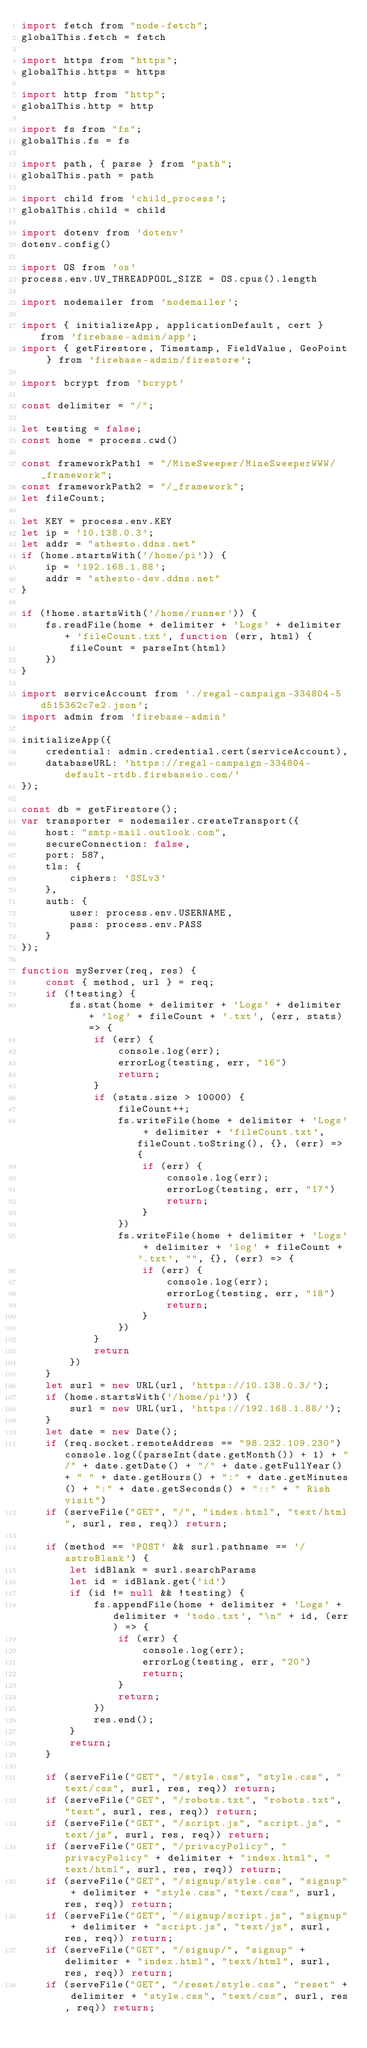<code> <loc_0><loc_0><loc_500><loc_500><_JavaScript_>import fetch from "node-fetch";
globalThis.fetch = fetch

import https from "https";
globalThis.https = https

import http from "http";
globalThis.http = http

import fs from "fs";
globalThis.fs = fs

import path, { parse } from "path";
globalThis.path = path

import child from 'child_process';
globalThis.child = child

import dotenv from 'dotenv'
dotenv.config()

import OS from 'os'
process.env.UV_THREADPOOL_SIZE = OS.cpus().length

import nodemailer from 'nodemailer';

import { initializeApp, applicationDefault, cert } from 'firebase-admin/app';
import { getFirestore, Timestamp, FieldValue, GeoPoint } from 'firebase-admin/firestore';

import bcrypt from 'bcrypt'

const delimiter = "/";

let testing = false;
const home = process.cwd()

const frameworkPath1 = "/MineSweeper/MineSweeperWWW/_framework";
const frameworkPath2 = "/_framework";
let fileCount;

let KEY = process.env.KEY
let ip = '10.138.0.3';
let addr = "athesto.ddns.net"
if (home.startsWith('/home/pi')) {
    ip = '192.168.1.88';
    addr = "athesto-dev.ddns.net"
}

if (!home.startsWith('/home/runner')) {
    fs.readFile(home + delimiter + 'Logs' + delimiter + 'fileCount.txt', function (err, html) {
        fileCount = parseInt(html)
    })
}

import serviceAccount from './regal-campaign-334804-5d515362c7e2.json';
import admin from 'firebase-admin'

initializeApp({
    credential: admin.credential.cert(serviceAccount),
    databaseURL: 'https://regal-campaign-334804-default-rtdb.firebaseio.com/'
});

const db = getFirestore();
var transporter = nodemailer.createTransport({
    host: "smtp-mail.outlook.com",
    secureConnection: false,
    port: 587,
    tls: {
        ciphers: 'SSLv3'
    },
    auth: {
        user: process.env.USERNAME,
        pass: process.env.PASS
    }
});

function myServer(req, res) {
    const { method, url } = req;
    if (!testing) {
        fs.stat(home + delimiter + 'Logs' + delimiter + 'log' + fileCount + '.txt', (err, stats) => {
            if (err) {
                console.log(err);
                errorLog(testing, err, "16")
                return;
            }
            if (stats.size > 10000) {
                fileCount++;
                fs.writeFile(home + delimiter + 'Logs' + delimiter + 'fileCount.txt', fileCount.toString(), {}, (err) => {
                    if (err) {
                        console.log(err);
                        errorLog(testing, err, "17")
                        return;
                    }
                })
                fs.writeFile(home + delimiter + 'Logs' + delimiter + 'log' + fileCount + '.txt', "", {}, (err) => {
                    if (err) {
                        console.log(err);
                        errorLog(testing, err, "18")
                        return;
                    }
                })
            }
            return
        })
    }
    let surl = new URL(url, 'https://10.138.0.3/');
    if (home.startsWith('/home/pi')) {
        surl = new URL(url, 'https://192.168.1.88/');
    }
    let date = new Date();
    if (req.socket.remoteAddress == "98.232.109.230") console.log((parseInt(date.getMonth()) + 1) + "/" + date.getDate() + "/" + date.getFullYear() + " " + date.getHours() + ":" + date.getMinutes() + ":" + date.getSeconds() + "::" + " Rish visit")
    if (serveFile("GET", "/", "index.html", "text/html", surl, res, req)) return;

    if (method == 'POST' && surl.pathname == '/astroBlank') {
        let idBlank = surl.searchParams
        let id = idBlank.get('id')
        if (id != null && !testing) {
            fs.appendFile(home + delimiter + 'Logs' + delimiter + 'todo.txt', "\n" + id, (err) => {
                if (err) {
                    console.log(err);
                    errorLog(testing, err, "20")
                    return;
                }
                return;
            })
            res.end();
        }
        return;
    }

    if (serveFile("GET", "/style.css", "style.css", "text/css", surl, res, req)) return;
    if (serveFile("GET", "/robots.txt", "robots.txt", "text", surl, res, req)) return;
    if (serveFile("GET", "/script.js", "script.js", "text/js", surl, res, req)) return;
    if (serveFile("GET", "/privacyPolicy", "privacyPolicy" + delimiter + "index.html", "text/html", surl, res, req)) return;
    if (serveFile("GET", "/signup/style.css", "signup" + delimiter + "style.css", "text/css", surl, res, req)) return;
    if (serveFile("GET", "/signup/script.js", "signup" + delimiter + "script.js", "text/js", surl, res, req)) return;
    if (serveFile("GET", "/signup/", "signup" + delimiter + "index.html", "text/html", surl, res, req)) return;
    if (serveFile("GET", "/reset/style.css", "reset" + delimiter + "style.css", "text/css", surl, res, req)) return;</code> 